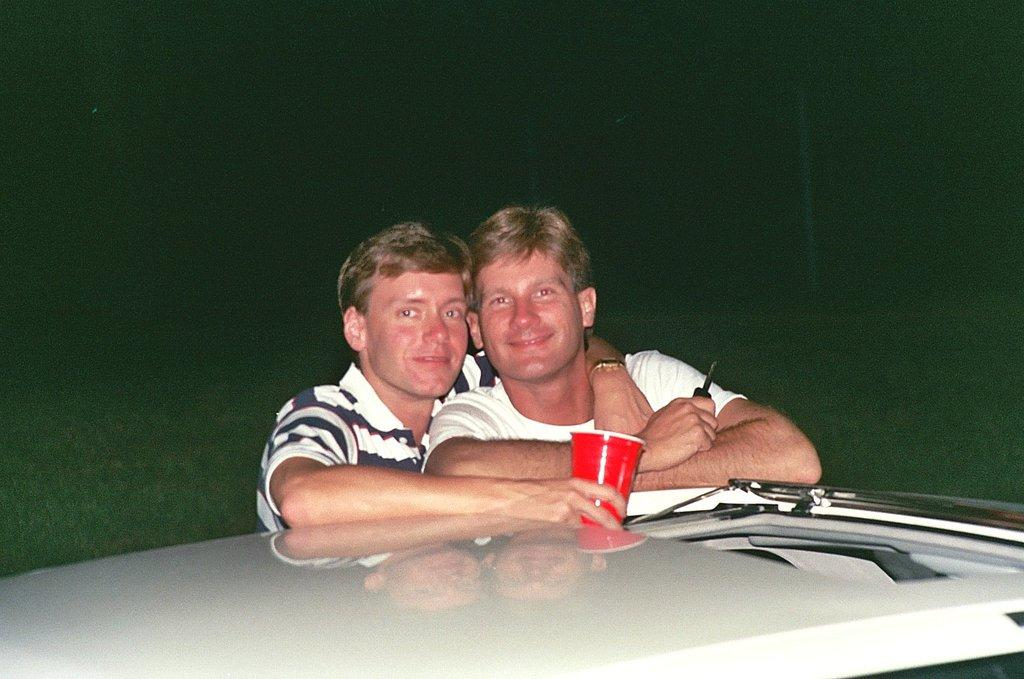How many people are in the image? There are two men in the image. What is the facial expression of the men? The men are smiling. What is one of the men holding? One of the men is holding a glass. What is in front of the men? There is a white platform in front of the men. How would you describe the background of the image? The background of the image is dark. Is there a veil covering the men's faces in the image? No, there is no veil present in the image. What type of stem can be seen growing from the platform in the image? There are no stems visible in the image; only a white platform is present. 